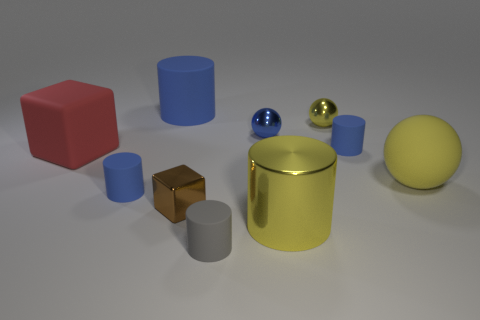Is there anything else that has the same shape as the tiny gray object?
Your answer should be very brief. Yes. What is the color of the big cylinder that is made of the same material as the brown cube?
Your answer should be very brief. Yellow. How many objects are either yellow shiny balls or large yellow rubber cylinders?
Your answer should be compact. 1. There is a blue shiny sphere; is it the same size as the blue cylinder that is on the right side of the big metal thing?
Make the answer very short. Yes. What color is the shiny sphere on the right side of the tiny ball to the left of the metallic ball right of the big yellow shiny object?
Your answer should be compact. Yellow. What color is the large matte sphere?
Provide a short and direct response. Yellow. Are there more small blue objects behind the yellow matte sphere than large blue objects that are in front of the brown block?
Ensure brevity in your answer.  Yes. Is the shape of the small brown shiny object the same as the yellow thing that is behind the red thing?
Your response must be concise. No. There is a matte object in front of the shiny block; is it the same size as the yellow shiny object in front of the red rubber cube?
Provide a short and direct response. No. Are there any large cylinders that are in front of the small blue rubber cylinder that is behind the matte cylinder left of the big blue matte cylinder?
Your answer should be very brief. Yes. 